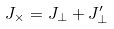Convert formula to latex. <formula><loc_0><loc_0><loc_500><loc_500>J _ { \times } = J _ { \perp } + J ^ { \prime } _ { \perp }</formula> 